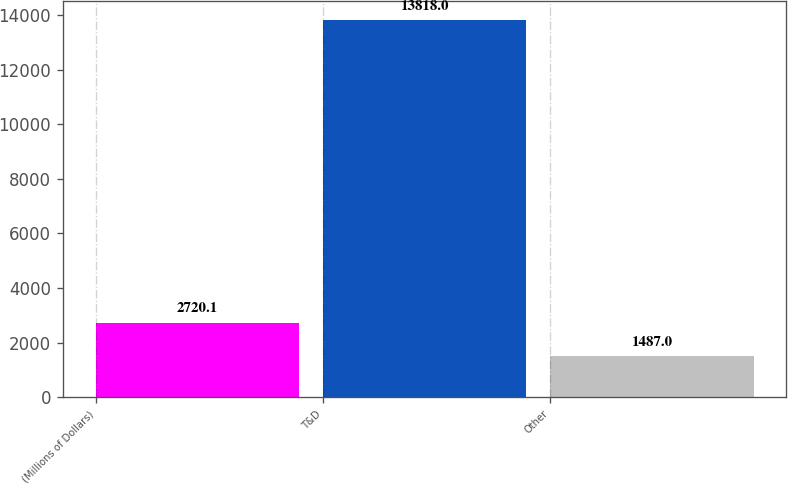<chart> <loc_0><loc_0><loc_500><loc_500><bar_chart><fcel>(Millions of Dollars)<fcel>T&D<fcel>Other<nl><fcel>2720.1<fcel>13818<fcel>1487<nl></chart> 